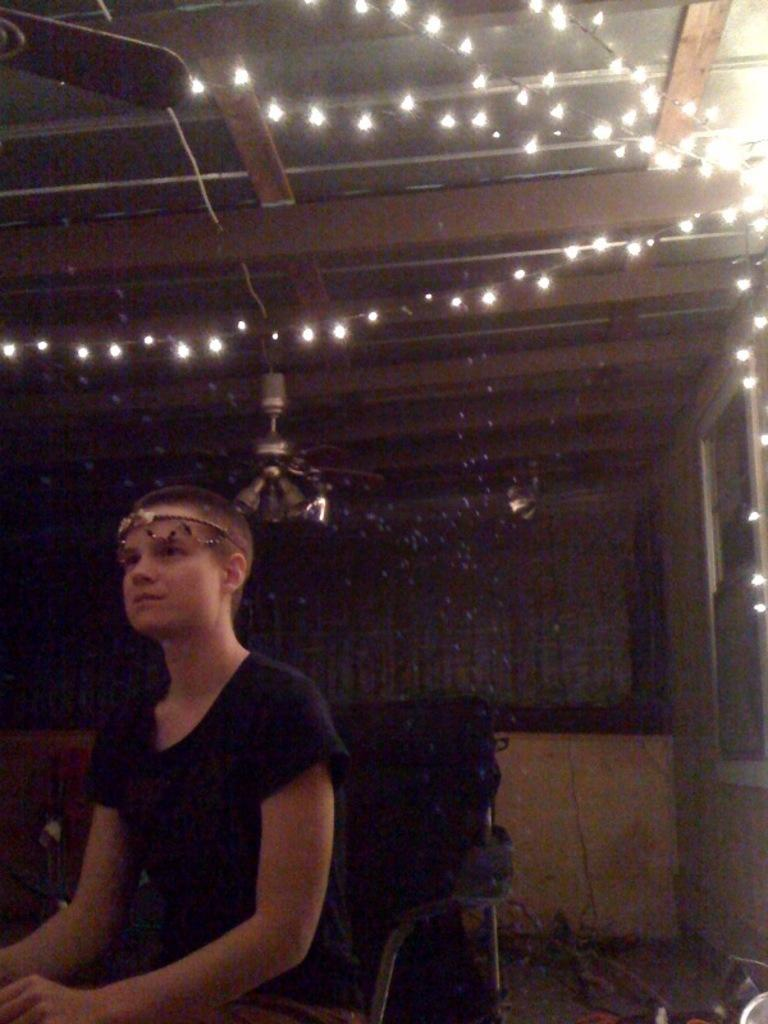What is the person in the image doing? The person is sitting on a chair in the image. What can be seen behind the person? There is a wall in the background of the image. What type of lighting is present in the image? Decorative lights are present in the image. What is visible above the person? There is a ceiling visible in the image. What is attached to the ceiling? Fans are attached to the ceiling. What type of crack can be seen on the person's face in the image? There is no crack visible on the person's face in the image. 